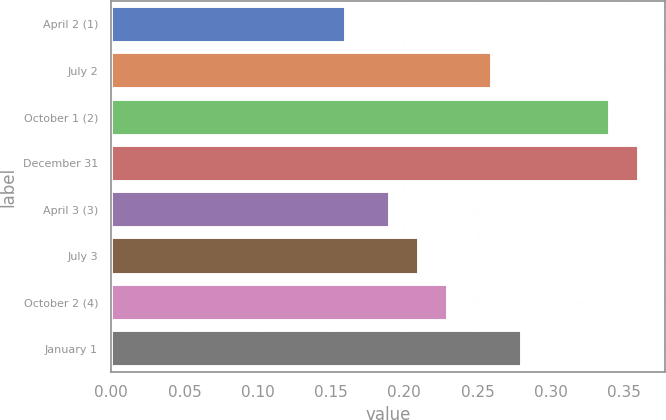Convert chart. <chart><loc_0><loc_0><loc_500><loc_500><bar_chart><fcel>April 2 (1)<fcel>July 2<fcel>October 1 (2)<fcel>December 31<fcel>April 3 (3)<fcel>July 3<fcel>October 2 (4)<fcel>January 1<nl><fcel>0.16<fcel>0.26<fcel>0.34<fcel>0.36<fcel>0.19<fcel>0.21<fcel>0.23<fcel>0.28<nl></chart> 